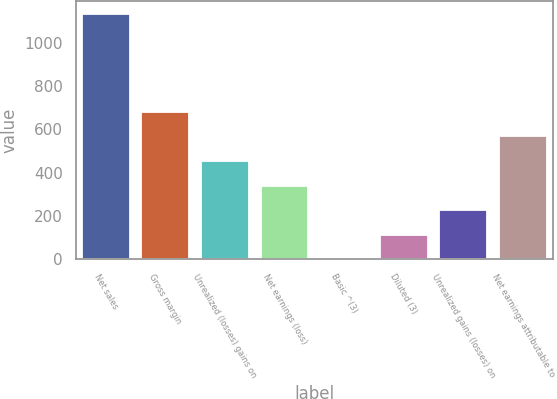Convert chart. <chart><loc_0><loc_0><loc_500><loc_500><bar_chart><fcel>Net sales<fcel>Gross margin<fcel>Unrealized (losses) gains on<fcel>Net earnings (loss)<fcel>Basic ^(3)<fcel>Diluted (3)<fcel>Unrealized gains (losses) on<fcel>Net earnings attributable to<nl><fcel>1134<fcel>680.48<fcel>453.72<fcel>340.34<fcel>0.2<fcel>113.58<fcel>226.96<fcel>567.1<nl></chart> 